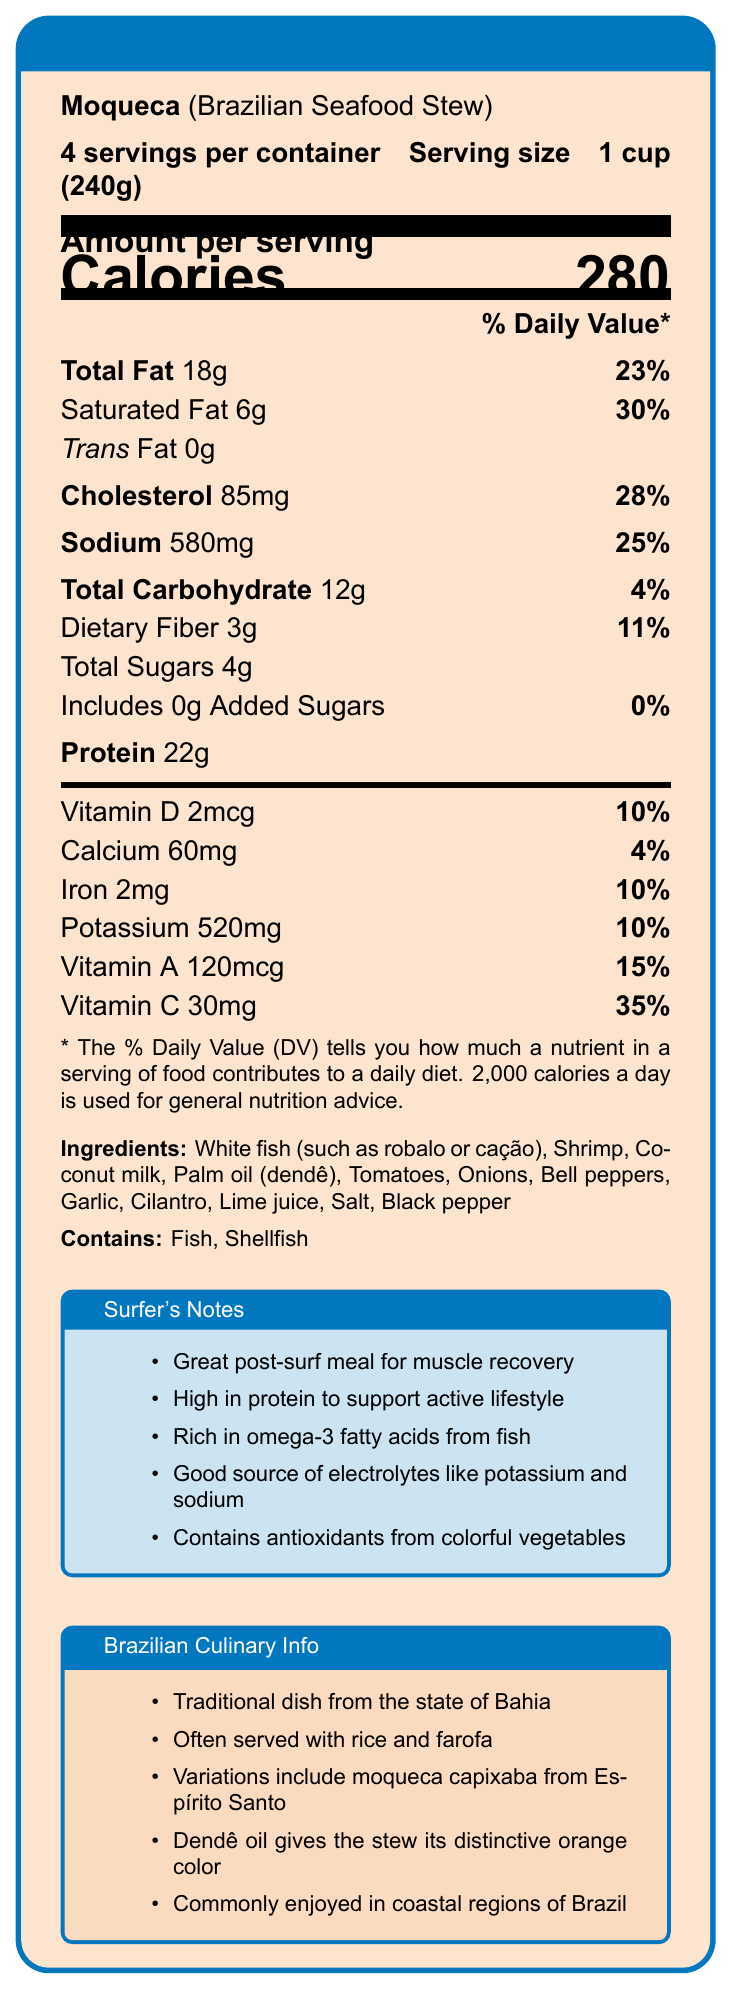What is the serving size for moqueca? The document specifies the serving size as 1 cup (240g).
Answer: 1 cup (240g) How many servings are there per container of moqueca? The document states there are 4 servings per container.
Answer: 4 How many calories are in one serving of moqueca? The nutrition facts section shows that one serving contains 280 calories.
Answer: 280 What is the amount of protein in one serving of moqueca? The document lists the protein content per serving as 22g.
Answer: 22g List the main ingredients used in moqueca. The ingredients section of the document provides this list.
Answer: White fish, Shrimp, Coconut milk, Palm oil (dendê), Tomatoes, Onions, Bell peppers, Garlic, Cilantro, Lime juice, Salt, Black pepper What percentage of the daily value does the saturated fat in moqueca contribute? The document shows that the saturated fat amount is 6g, which is 30% of the daily value.
Answer: 30% Which of the following is not an ingredient in moqueca? A. Lime juice B. Pineapple C. Shrimp D. Tomatoes The document lists Lime juice, Shrimp, and Tomatoes as ingredients, but not Pineapple.
Answer: B. Pineapple What is the amount of sodium in one serving of moqueca? The sodium content per serving is listed as 580mg.
Answer: 580mg Does the moqueca contain any added sugars? The document states that there are 0g of added sugars in moqueca.
Answer: No Where is the moqueca dish traditionally from? A. Rio de Janeiro B. Bahia C. São Paulo D. Minas Gerais The Brazilian Culinary Info section mentions that moqueca is a traditional dish from the state of Bahia.
Answer: B. Bahia Is moqueca a good source of Vitamin C? The document shows that one serving provides 35% of the daily value for Vitamin C, indicating it as a good source.
Answer: Yes Summarize the key points of the Nutrition Facts Label for moqueca. This comprehensive summary covers the main nutritional details, ingredients, allergens, benefits for surfers, and cultural information provided in the document.
Answer: The document provides nutritional information for moqueca, a traditional Brazilian seafood stew, with key highlights per serving: 280 calories, 18g total fat, 6g saturated fat, 85mg cholesterol, 580mg sodium, 12g carbohydrate, 3g fiber, 4g total sugars, and 22g protein. It also lists vitamins and minerals such as Vitamin D, Calcium, Iron, Potassium, Vitamin A, and Vitamin C. Main ingredients include fish, shrimp, and various vegetables, and it contains allergens like fish and shellfish. The label also provides benefits such as high protein and richness in omega-3 fatty acids, and contains cultural and culinary insights about the dish. How much of the daily value of potassium does one serving of moqueca provide? The potassium content per serving is 520mg, which is 10% of the daily value.
Answer: 10% How does the color of moqueca get its distinctive orange hue? The Brazilian Culinary Info section notes that dendê oil gives the stew its distinctive orange color.
Answer: From dendê oil Is moqueca commonly enjoyed in inland regions of Brazil? The document mentions it is commonly enjoyed in coastal regions but does not provide information about its popularity in inland regions.
Answer: Cannot be determined 